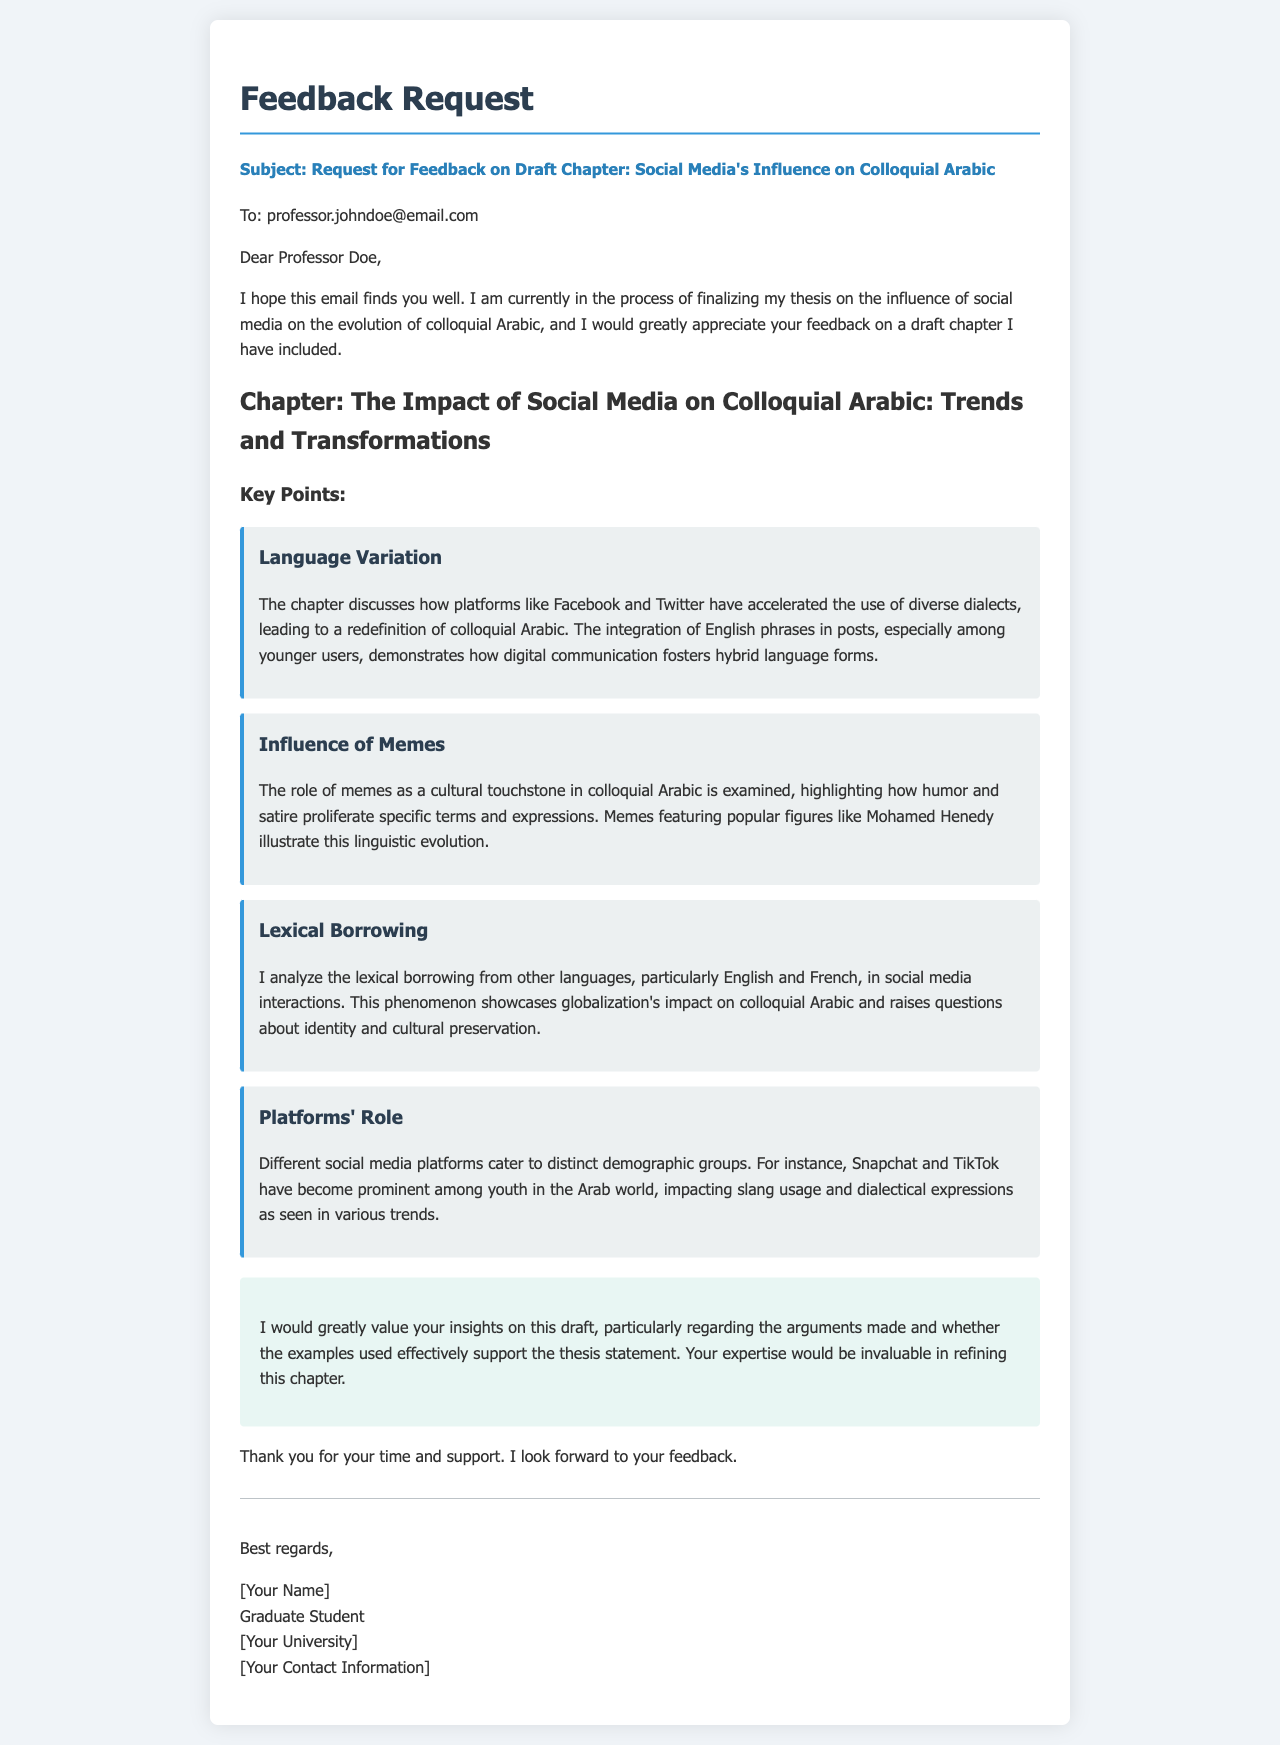What is the title of the chapter discussed? The title of the chapter is explicitly mentioned in the document.
Answer: The Impact of Social Media on Colloquial Arabic: Trends and Transformations Who is the email addressed to? The document clearly states the recipient of the email.
Answer: Professor Doe What social media platforms are mentioned in relation to youth use? The document provides specific examples of social media platforms appealing to youth.
Answer: Snapchat and TikTok What is one key point related to language mentioned in the draft? Several key points are listed; one specifically addresses language variation.
Answer: Language Variation What type of content does the chapter analyze regarding lexical borrowing? The document focuses on specific languages that influence colloquial Arabic.
Answer: English and French What is the main purpose of the feedback request? The intention behind requesting feedback is articulated in the email.
Answer: To refine the chapter How does the draft mention memes in the context of colloquial Arabic? Several key points summarize the role of memes regarding specific terms and expressions.
Answer: As a cultural touchstone What does the writer hope to gain from the professor's feedback? The document indicates the writer's hope for specific insights from the feedback.
Answer: Insights on arguments and examples 